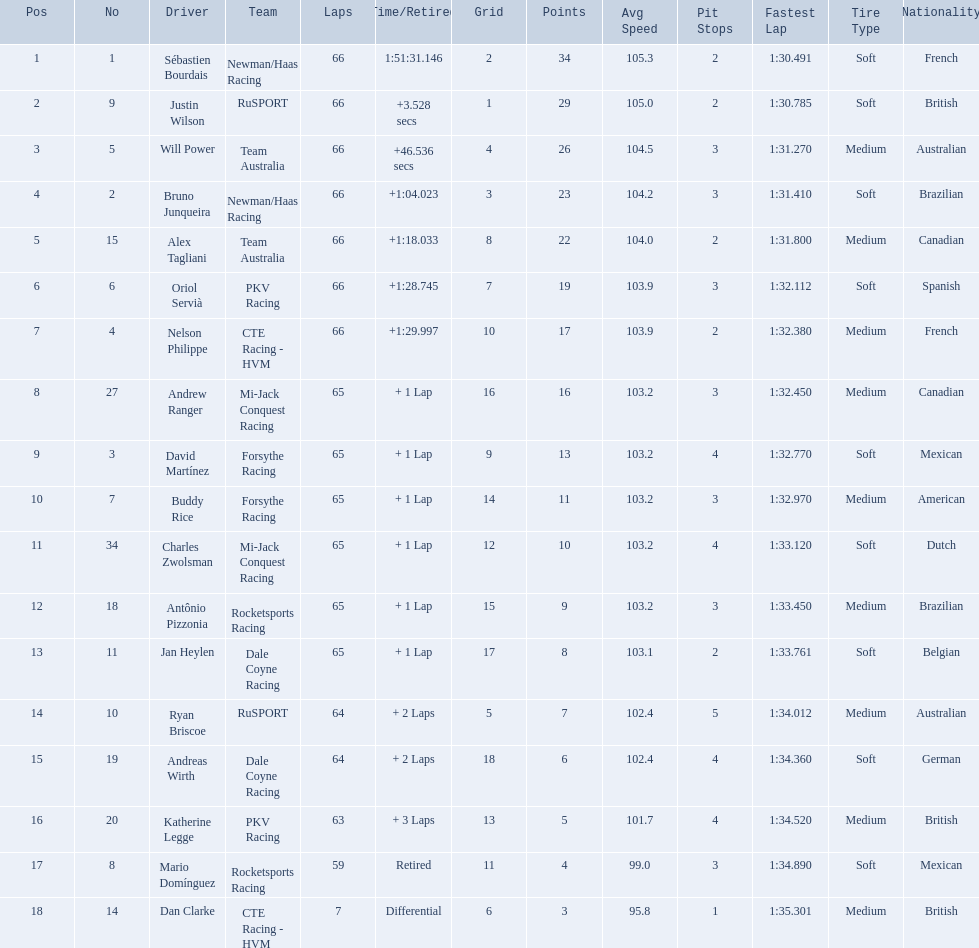Which teams participated in the 2006 gran premio telmex? Newman/Haas Racing, RuSPORT, Team Australia, Newman/Haas Racing, Team Australia, PKV Racing, CTE Racing - HVM, Mi-Jack Conquest Racing, Forsythe Racing, Forsythe Racing, Mi-Jack Conquest Racing, Rocketsports Racing, Dale Coyne Racing, RuSPORT, Dale Coyne Racing, PKV Racing, Rocketsports Racing, CTE Racing - HVM. Who were the drivers of these teams? Sébastien Bourdais, Justin Wilson, Will Power, Bruno Junqueira, Alex Tagliani, Oriol Servià, Nelson Philippe, Andrew Ranger, David Martínez, Buddy Rice, Charles Zwolsman, Antônio Pizzonia, Jan Heylen, Ryan Briscoe, Andreas Wirth, Katherine Legge, Mario Domínguez, Dan Clarke. Which driver finished last? Dan Clarke. 